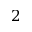Convert formula to latex. <formula><loc_0><loc_0><loc_500><loc_500>2</formula> 